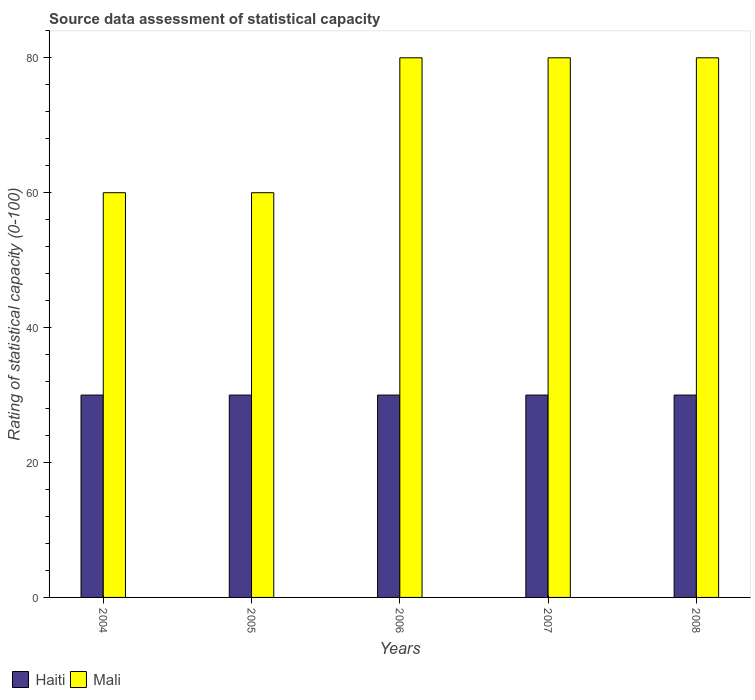How many different coloured bars are there?
Provide a succinct answer. 2. How many groups of bars are there?
Offer a very short reply. 5. Are the number of bars per tick equal to the number of legend labels?
Your answer should be very brief. Yes. Are the number of bars on each tick of the X-axis equal?
Give a very brief answer. Yes. How many bars are there on the 3rd tick from the left?
Give a very brief answer. 2. What is the label of the 5th group of bars from the left?
Provide a short and direct response. 2008. What is the rating of statistical capacity in Mali in 2004?
Your response must be concise. 60. Across all years, what is the maximum rating of statistical capacity in Mali?
Make the answer very short. 80. Across all years, what is the minimum rating of statistical capacity in Mali?
Your answer should be very brief. 60. In which year was the rating of statistical capacity in Mali minimum?
Your response must be concise. 2004. What is the total rating of statistical capacity in Haiti in the graph?
Give a very brief answer. 150. What is the difference between the rating of statistical capacity in Mali in 2005 and that in 2007?
Make the answer very short. -20. What is the difference between the rating of statistical capacity in Mali in 2006 and the rating of statistical capacity in Haiti in 2004?
Your response must be concise. 50. What is the average rating of statistical capacity in Mali per year?
Your answer should be compact. 72. In the year 2007, what is the difference between the rating of statistical capacity in Mali and rating of statistical capacity in Haiti?
Give a very brief answer. 50. In how many years, is the rating of statistical capacity in Mali greater than 60?
Ensure brevity in your answer.  3. Is the rating of statistical capacity in Mali in 2004 less than that in 2006?
Offer a very short reply. Yes. What is the difference between the highest and the second highest rating of statistical capacity in Mali?
Give a very brief answer. 0. What is the difference between the highest and the lowest rating of statistical capacity in Mali?
Make the answer very short. 20. Is the sum of the rating of statistical capacity in Mali in 2006 and 2007 greater than the maximum rating of statistical capacity in Haiti across all years?
Your answer should be compact. Yes. What does the 2nd bar from the left in 2008 represents?
Make the answer very short. Mali. What does the 1st bar from the right in 2007 represents?
Provide a succinct answer. Mali. How many bars are there?
Your response must be concise. 10. Does the graph contain any zero values?
Ensure brevity in your answer.  No. Where does the legend appear in the graph?
Make the answer very short. Bottom left. How many legend labels are there?
Make the answer very short. 2. How are the legend labels stacked?
Ensure brevity in your answer.  Horizontal. What is the title of the graph?
Your answer should be compact. Source data assessment of statistical capacity. Does "Singapore" appear as one of the legend labels in the graph?
Offer a very short reply. No. What is the label or title of the Y-axis?
Your answer should be compact. Rating of statistical capacity (0-100). What is the Rating of statistical capacity (0-100) in Haiti in 2004?
Give a very brief answer. 30. What is the Rating of statistical capacity (0-100) in Mali in 2004?
Your response must be concise. 60. What is the Rating of statistical capacity (0-100) of Mali in 2005?
Provide a short and direct response. 60. What is the Rating of statistical capacity (0-100) in Haiti in 2006?
Your answer should be compact. 30. What is the Rating of statistical capacity (0-100) in Mali in 2006?
Ensure brevity in your answer.  80. What is the Rating of statistical capacity (0-100) in Haiti in 2007?
Your answer should be compact. 30. What is the Rating of statistical capacity (0-100) in Mali in 2007?
Offer a very short reply. 80. Across all years, what is the maximum Rating of statistical capacity (0-100) of Haiti?
Provide a succinct answer. 30. What is the total Rating of statistical capacity (0-100) in Haiti in the graph?
Make the answer very short. 150. What is the total Rating of statistical capacity (0-100) in Mali in the graph?
Your answer should be compact. 360. What is the difference between the Rating of statistical capacity (0-100) of Haiti in 2004 and that in 2005?
Your answer should be very brief. 0. What is the difference between the Rating of statistical capacity (0-100) in Mali in 2004 and that in 2005?
Your answer should be very brief. 0. What is the difference between the Rating of statistical capacity (0-100) of Mali in 2004 and that in 2006?
Give a very brief answer. -20. What is the difference between the Rating of statistical capacity (0-100) of Haiti in 2004 and that in 2007?
Your answer should be very brief. 0. What is the difference between the Rating of statistical capacity (0-100) in Mali in 2004 and that in 2007?
Your answer should be compact. -20. What is the difference between the Rating of statistical capacity (0-100) of Haiti in 2005 and that in 2007?
Ensure brevity in your answer.  0. What is the difference between the Rating of statistical capacity (0-100) of Mali in 2005 and that in 2007?
Offer a very short reply. -20. What is the difference between the Rating of statistical capacity (0-100) of Mali in 2005 and that in 2008?
Your answer should be compact. -20. What is the difference between the Rating of statistical capacity (0-100) in Mali in 2006 and that in 2008?
Your response must be concise. 0. What is the difference between the Rating of statistical capacity (0-100) in Haiti in 2007 and that in 2008?
Offer a very short reply. 0. What is the difference between the Rating of statistical capacity (0-100) of Haiti in 2004 and the Rating of statistical capacity (0-100) of Mali in 2005?
Offer a very short reply. -30. What is the difference between the Rating of statistical capacity (0-100) in Haiti in 2004 and the Rating of statistical capacity (0-100) in Mali in 2007?
Provide a succinct answer. -50. What is the difference between the Rating of statistical capacity (0-100) of Haiti in 2005 and the Rating of statistical capacity (0-100) of Mali in 2007?
Offer a very short reply. -50. What is the difference between the Rating of statistical capacity (0-100) in Haiti in 2005 and the Rating of statistical capacity (0-100) in Mali in 2008?
Make the answer very short. -50. What is the difference between the Rating of statistical capacity (0-100) in Haiti in 2006 and the Rating of statistical capacity (0-100) in Mali in 2007?
Your answer should be compact. -50. In the year 2006, what is the difference between the Rating of statistical capacity (0-100) in Haiti and Rating of statistical capacity (0-100) in Mali?
Keep it short and to the point. -50. In the year 2007, what is the difference between the Rating of statistical capacity (0-100) in Haiti and Rating of statistical capacity (0-100) in Mali?
Give a very brief answer. -50. In the year 2008, what is the difference between the Rating of statistical capacity (0-100) of Haiti and Rating of statistical capacity (0-100) of Mali?
Your answer should be very brief. -50. What is the ratio of the Rating of statistical capacity (0-100) of Haiti in 2004 to that in 2006?
Ensure brevity in your answer.  1. What is the ratio of the Rating of statistical capacity (0-100) of Haiti in 2004 to that in 2007?
Ensure brevity in your answer.  1. What is the ratio of the Rating of statistical capacity (0-100) of Haiti in 2004 to that in 2008?
Ensure brevity in your answer.  1. What is the ratio of the Rating of statistical capacity (0-100) of Mali in 2004 to that in 2008?
Give a very brief answer. 0.75. What is the ratio of the Rating of statistical capacity (0-100) of Haiti in 2005 to that in 2006?
Offer a very short reply. 1. What is the ratio of the Rating of statistical capacity (0-100) in Mali in 2005 to that in 2006?
Your answer should be compact. 0.75. What is the ratio of the Rating of statistical capacity (0-100) in Mali in 2005 to that in 2007?
Make the answer very short. 0.75. What is the ratio of the Rating of statistical capacity (0-100) in Haiti in 2006 to that in 2008?
Offer a very short reply. 1. What is the ratio of the Rating of statistical capacity (0-100) in Mali in 2007 to that in 2008?
Make the answer very short. 1. What is the difference between the highest and the second highest Rating of statistical capacity (0-100) of Haiti?
Give a very brief answer. 0. What is the difference between the highest and the second highest Rating of statistical capacity (0-100) of Mali?
Ensure brevity in your answer.  0. What is the difference between the highest and the lowest Rating of statistical capacity (0-100) in Mali?
Offer a very short reply. 20. 